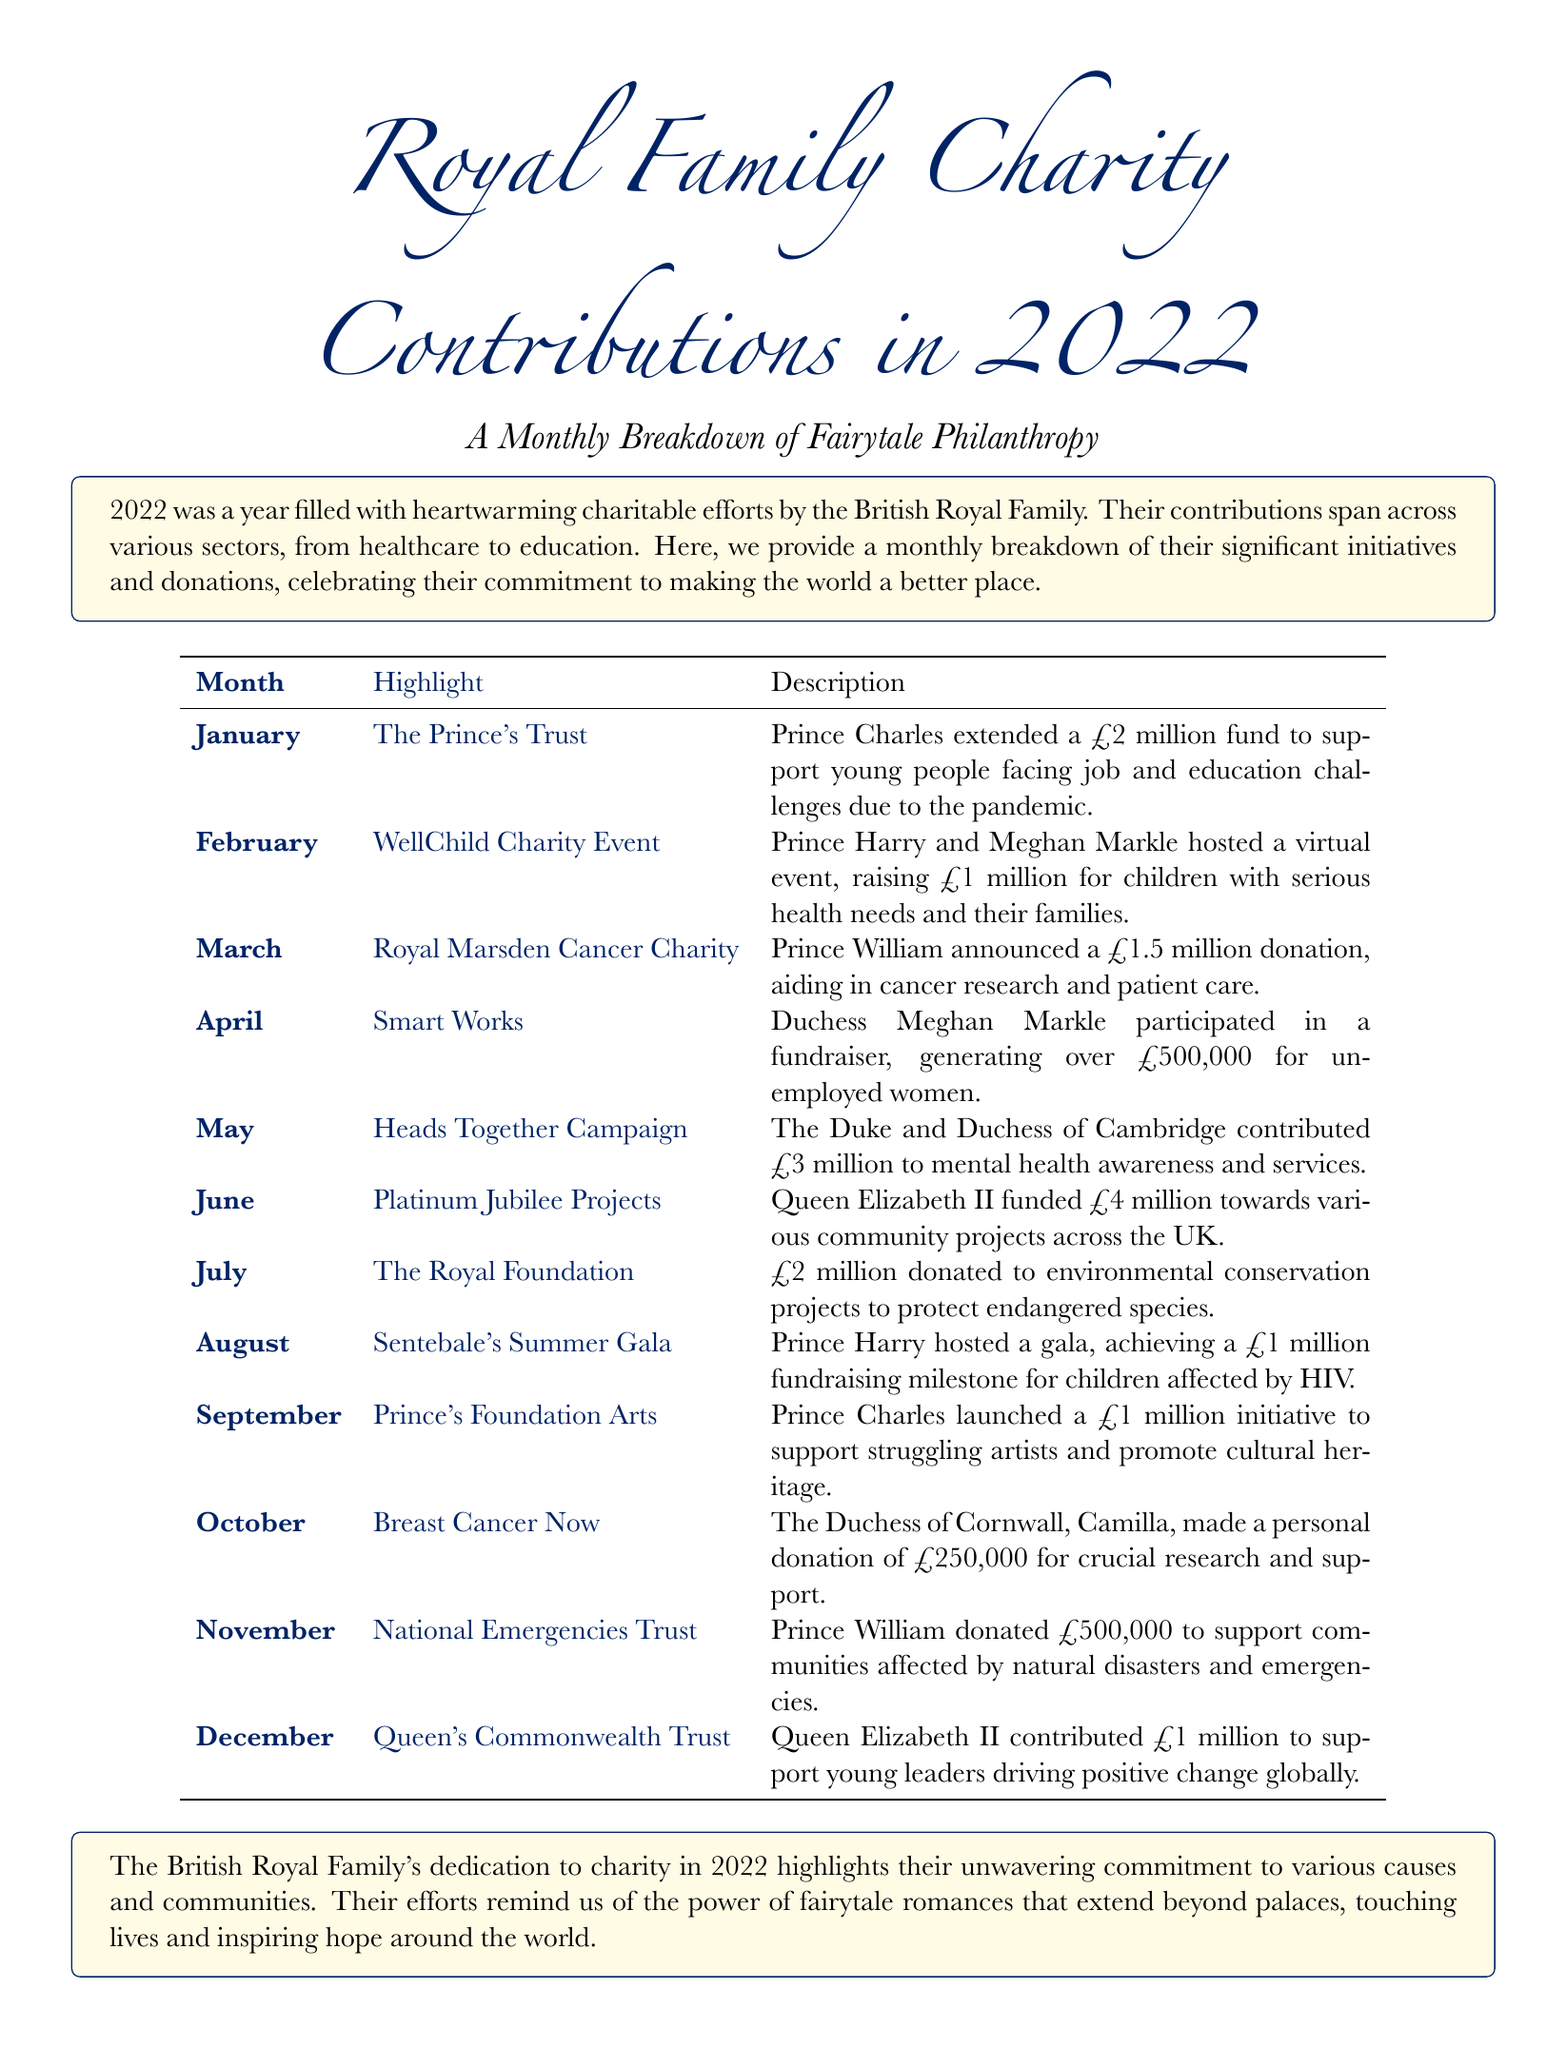What was the total amount donated in June? The total donation in June, as specified in the document, was £4 million for various community projects.
Answer: £4 million Which charity received a donation from the Duchess of Cornwall in October? The document states that the Duchess of Cornwall made a donation to Breast Cancer Now in October.
Answer: Breast Cancer Now How much did Prince William donate in November? According to the monthly breakdown, Prince William donated £500,000 to support communities affected by natural disasters.
Answer: £500,000 What event did Prince Harry host in August? The document mentions that Prince Harry hosted Sentebale's Summer Gala in August, raising funds for children affected by HIV.
Answer: Sentebale's Summer Gala Which month included a £3 million contribution to mental health awareness? In May, the Duke and Duchess of Cambridge contributed £3 million to the Heads Together Campaign for mental health awareness.
Answer: May How much was raised at the WellChild Charity Event in February? The document specifies that the WellChild Charity Event raised £1 million.
Answer: £1 million What is the total amount contributed by Queen Elizabeth II in 2022? The document lists two contributions by Queen Elizabeth II: £4 million in June and £1 million in December, totaling £5 million.
Answer: £5 million Which charity focused on environmental conservation in July? The Royal Foundation received £2 million for environmental conservation projects in July, as per the document.
Answer: The Royal Foundation What was the primary focus of the donation in March? In March, the donation of £1.5 million from Prince William was aimed at aiding cancer research and patient care.
Answer: Cancer research and patient care 